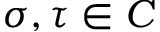<formula> <loc_0><loc_0><loc_500><loc_500>\sigma , \tau \in C</formula> 